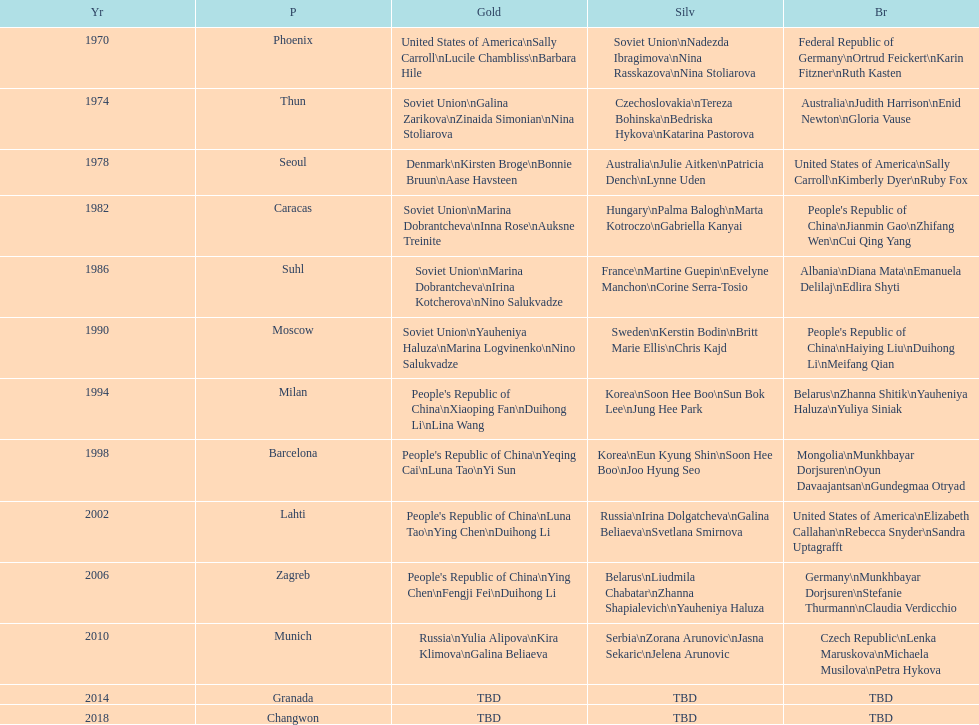What is the number of total bronze medals that germany has won? 1. 